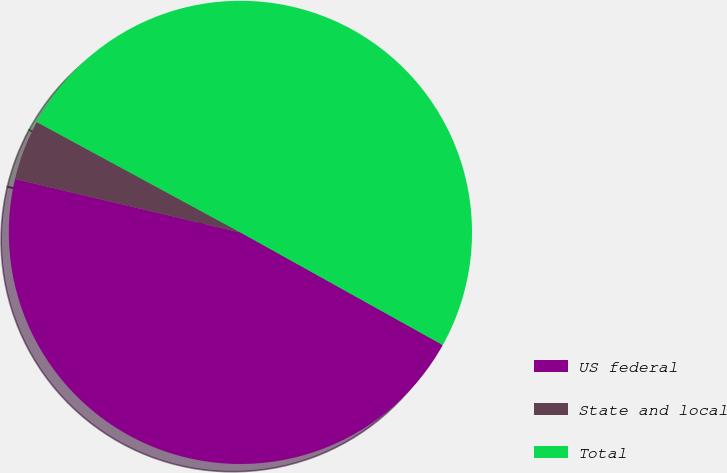Convert chart. <chart><loc_0><loc_0><loc_500><loc_500><pie_chart><fcel>US federal<fcel>State and local<fcel>Total<nl><fcel>45.62%<fcel>4.2%<fcel>50.18%<nl></chart> 